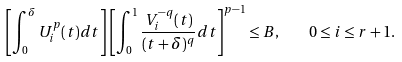Convert formula to latex. <formula><loc_0><loc_0><loc_500><loc_500>\left [ \int _ { 0 } ^ { \delta } U _ { i } ^ { p } ( t ) d t \right ] \left [ \int _ { 0 } ^ { 1 } \frac { V _ { i } ^ { - q } ( t ) } { ( t + \delta ) ^ { q } } d t \right ] ^ { p - 1 } \leq B , \quad 0 \leq i \leq r + 1 .</formula> 